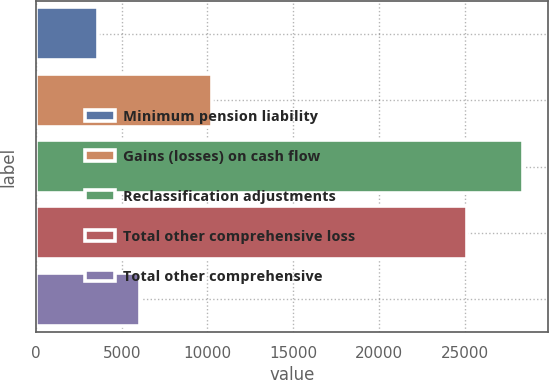<chart> <loc_0><loc_0><loc_500><loc_500><bar_chart><fcel>Minimum pension liability<fcel>Gains (losses) on cash flow<fcel>Reclassification adjustments<fcel>Total other comprehensive loss<fcel>Total other comprehensive<nl><fcel>3617<fcel>10255<fcel>28435<fcel>25156<fcel>6098.8<nl></chart> 